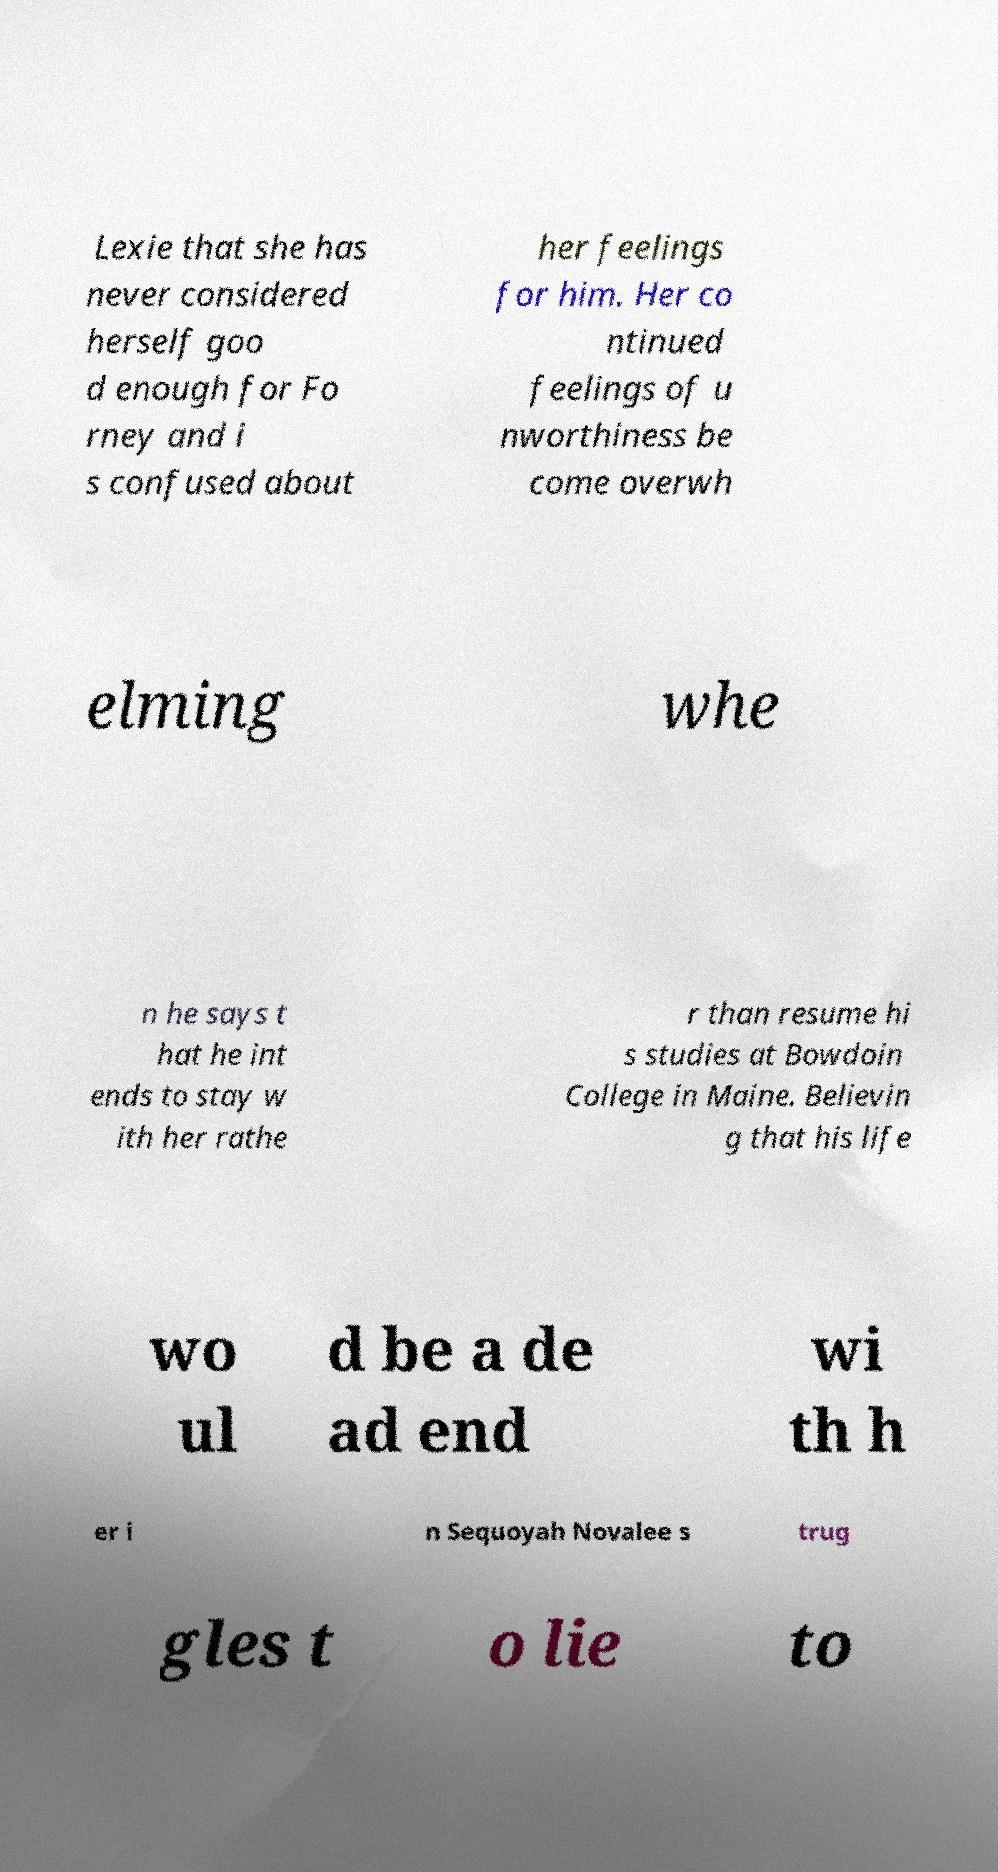I need the written content from this picture converted into text. Can you do that? Lexie that she has never considered herself goo d enough for Fo rney and i s confused about her feelings for him. Her co ntinued feelings of u nworthiness be come overwh elming whe n he says t hat he int ends to stay w ith her rathe r than resume hi s studies at Bowdoin College in Maine. Believin g that his life wo ul d be a de ad end wi th h er i n Sequoyah Novalee s trug gles t o lie to 